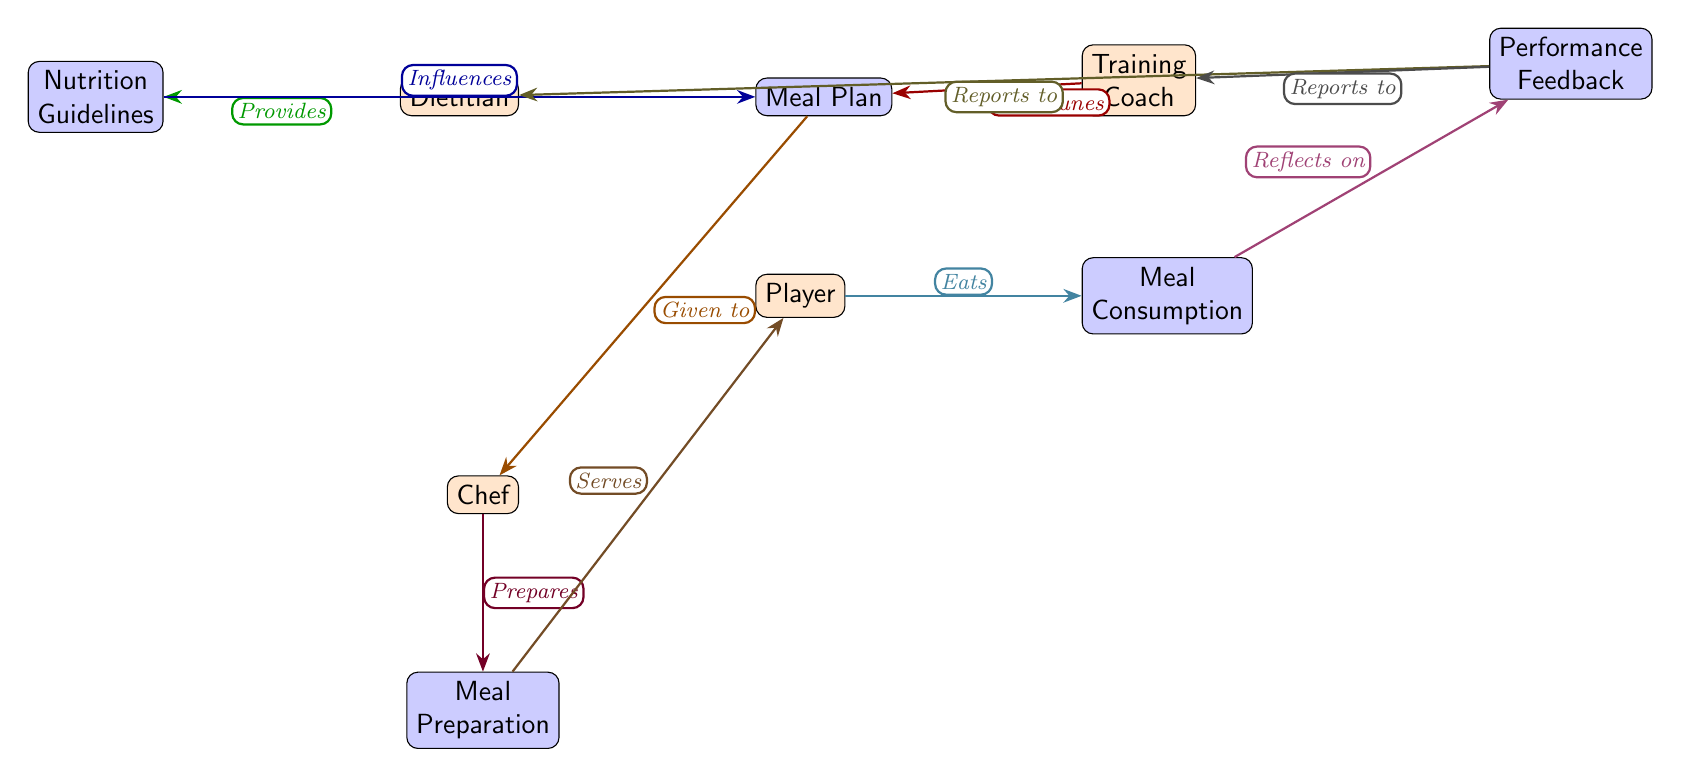What role does the dietitian play in the food chain? The diagram identifies the dietitian as providing "Nutrition Guidelines" to the player, which is a key role in ensuring that the player's dietary intake aligns with performance needs.
Answer: Provides Nutrition Guidelines How many people are involved in the food chain? The diagram includes four distinct individuals: the player, dietitian, chef, and coach, totaling four people directly involved in the nutritional process.
Answer: Four What does the player do with the meal prepared by the chef? According to the diagram, the player "Eats" the meal that has been served, indicating that the meal consumption is a direct action taken by the player after preparation.
Answer: Eats Which node receives feedback from the player? The diagram shows that the "Performance Feedback" node receives input from the player, indicating a correlation between the player's consumption and their subsequent performance evaluation.
Answer: Performance Feedback How does the meal plan get prepared? The diagram details that the meal plan, influenced by nutrition guidelines and fine-tuned by the coach, is "Given to" the chef for preparation, showing a collaborative effort for meal preparation.
Answer: Given to chef What influences the meal plan? The diagram indicates that both the dietitian, through the Nutrition Guidelines, and the coach, who fine-tunes the plan, together influence the creation of the meal plan.
Answer: Nutrition Guidelines and Coaching What does the meal consumption reflect on? The diagram illustrates that the act of meal consumption has a direct link to "Performance Feedback," suggesting that the player's dietary intake has implications on their performance outcomes.
Answer: Performance Feedback Who reports the performance feedback to the dietitian? The diagram indicates that the player provides feedback that is reported to the dietitian, establishing a communication loop aimed at enhancing nutritional strategies.
Answer: Player What happens after meal consumption? Following the act of meal consumption, the player reflects on their performance, as shown in the diagram, creating a feedback loop to improve future dietary decisions.
Answer: Reflects on Performance 